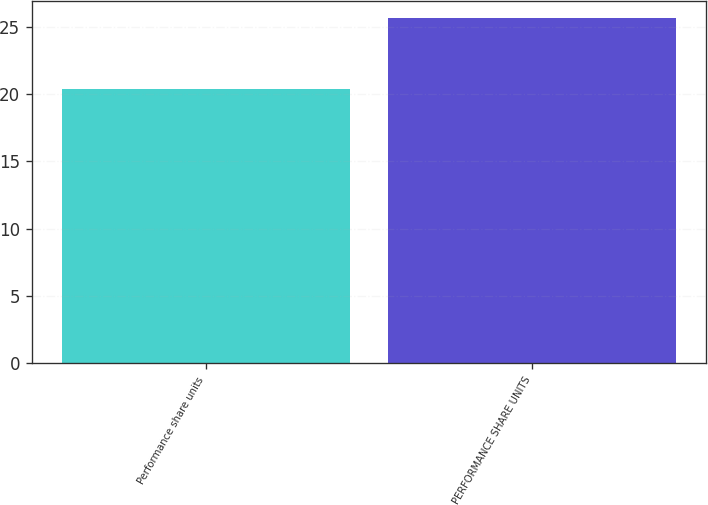Convert chart to OTSL. <chart><loc_0><loc_0><loc_500><loc_500><bar_chart><fcel>Performance share units<fcel>PERFORMANCE SHARE UNITS<nl><fcel>20.39<fcel>25.65<nl></chart> 